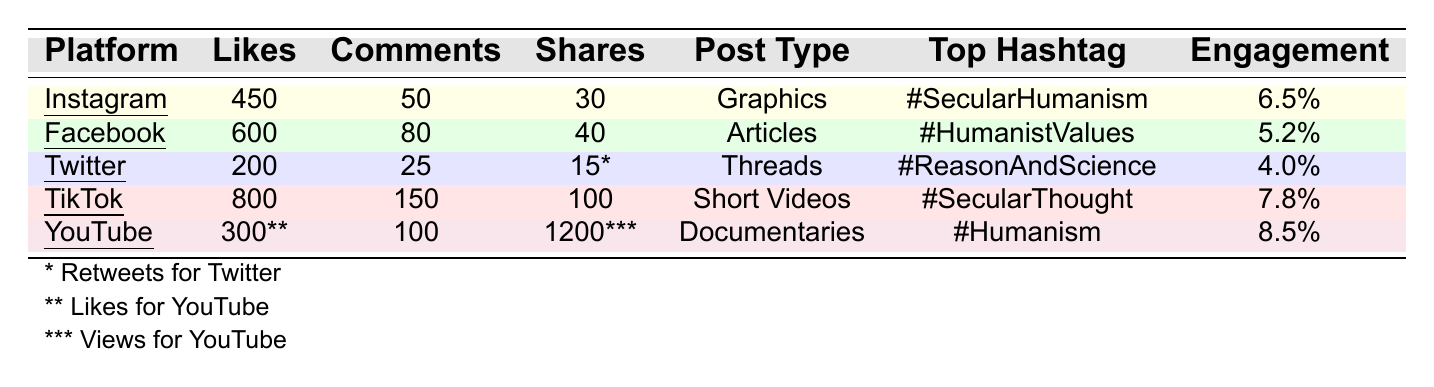What is the engagement rate for TikTok? The table shows that TikTok has an engagement rate listed as 7.8%.
Answer: 7.8% Which platform had the highest average likes? By comparing the average likes across all platforms, TikTok has the highest average likes at 800.
Answer: TikTok How many average shares did Instagram posts receive? The table indicates that Instagram received an average of 30 shares for its posts.
Answer: 30 What is the average number of comments for Facebook and Instagram combined? The average comments for Facebook is 80, and for Instagram, it is 50. Adding these gives 80 + 50 = 130.
Answer: 130 Is the top hashtag for YouTube equal to that of Twitter? The top hashtag for YouTube is #Humanism, while for Twitter it is #ReasonAndScience; these hashtags are different, so the statement is false.
Answer: No What is the total number of average likes across all platforms? The average likes per platform are: Instagram (450), Facebook (600), Twitter (200), TikTok (800), and YouTube (300). Summing these gives 450 + 600 + 200 + 800 + 300 = 2350.
Answer: 2350 Which post type has the most total average interactions (likes, comments, shares) on Facebook? For Facebook, the total interactions are calculated as follows: Likes (600) + Comments (80) + Shares (40) = 720. Out of all platforms, this has the second highest total interactions after TikTok (average likes + comments + shares = 800 + 150 + 100 = 1050).
Answer: 720 Are the engagement rates for TikTok and Instagram both above 6%? TikTok has an engagement rate of 7.8%, and Instagram has 6.5%. Both are above 6%, so the statement is true.
Answer: Yes What is the difference in average comments between TikTok and Twitter? TikTok has an average of 150 comments and Twitter has 25. The difference is calculated as 150 - 25 = 125.
Answer: 125 Which platform has the lowest engagement rate? From the engagement rates listed, Twitter has the lowest at 4.0%.
Answer: Twitter 